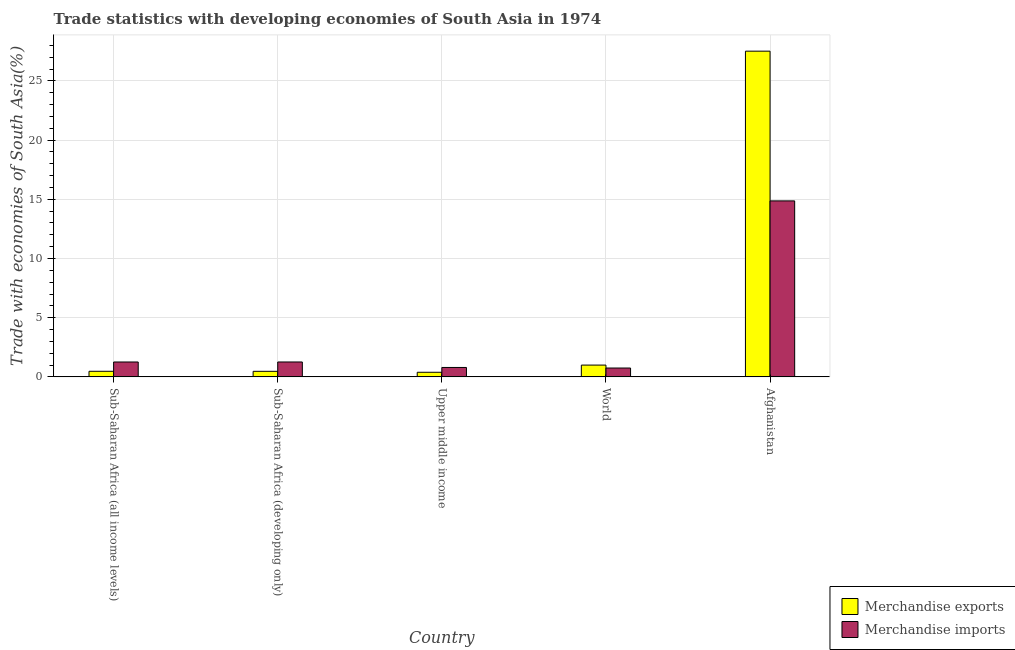Are the number of bars per tick equal to the number of legend labels?
Your answer should be very brief. Yes. Are the number of bars on each tick of the X-axis equal?
Your answer should be compact. Yes. How many bars are there on the 4th tick from the left?
Your response must be concise. 2. How many bars are there on the 2nd tick from the right?
Offer a very short reply. 2. What is the label of the 1st group of bars from the left?
Offer a very short reply. Sub-Saharan Africa (all income levels). In how many cases, is the number of bars for a given country not equal to the number of legend labels?
Your answer should be very brief. 0. What is the merchandise imports in Sub-Saharan Africa (developing only)?
Provide a short and direct response. 1.26. Across all countries, what is the maximum merchandise exports?
Offer a terse response. 27.51. Across all countries, what is the minimum merchandise exports?
Your response must be concise. 0.39. In which country was the merchandise imports maximum?
Make the answer very short. Afghanistan. What is the total merchandise exports in the graph?
Provide a short and direct response. 29.84. What is the difference between the merchandise exports in Afghanistan and that in Sub-Saharan Africa (all income levels)?
Ensure brevity in your answer.  27.04. What is the difference between the merchandise exports in Sub-Saharan Africa (all income levels) and the merchandise imports in Sub-Saharan Africa (developing only)?
Your response must be concise. -0.79. What is the average merchandise imports per country?
Provide a succinct answer. 3.78. What is the difference between the merchandise imports and merchandise exports in Sub-Saharan Africa (all income levels)?
Keep it short and to the point. 0.79. What is the ratio of the merchandise exports in Afghanistan to that in Sub-Saharan Africa (developing only)?
Provide a short and direct response. 58.75. Is the merchandise exports in Sub-Saharan Africa (all income levels) less than that in Upper middle income?
Keep it short and to the point. No. Is the difference between the merchandise exports in Afghanistan and Sub-Saharan Africa (developing only) greater than the difference between the merchandise imports in Afghanistan and Sub-Saharan Africa (developing only)?
Offer a terse response. Yes. What is the difference between the highest and the second highest merchandise exports?
Offer a very short reply. 26.52. What is the difference between the highest and the lowest merchandise exports?
Your answer should be very brief. 27.13. What does the 2nd bar from the left in Upper middle income represents?
Your answer should be compact. Merchandise imports. What does the 2nd bar from the right in Sub-Saharan Africa (all income levels) represents?
Offer a very short reply. Merchandise exports. Are all the bars in the graph horizontal?
Make the answer very short. No. Where does the legend appear in the graph?
Offer a terse response. Bottom right. What is the title of the graph?
Your answer should be very brief. Trade statistics with developing economies of South Asia in 1974. Does "Fixed telephone" appear as one of the legend labels in the graph?
Your answer should be very brief. No. What is the label or title of the Y-axis?
Provide a short and direct response. Trade with economies of South Asia(%). What is the Trade with economies of South Asia(%) of Merchandise exports in Sub-Saharan Africa (all income levels)?
Provide a short and direct response. 0.47. What is the Trade with economies of South Asia(%) of Merchandise imports in Sub-Saharan Africa (all income levels)?
Make the answer very short. 1.26. What is the Trade with economies of South Asia(%) in Merchandise exports in Sub-Saharan Africa (developing only)?
Your answer should be very brief. 0.47. What is the Trade with economies of South Asia(%) of Merchandise imports in Sub-Saharan Africa (developing only)?
Your answer should be very brief. 1.26. What is the Trade with economies of South Asia(%) of Merchandise exports in Upper middle income?
Give a very brief answer. 0.39. What is the Trade with economies of South Asia(%) in Merchandise imports in Upper middle income?
Your response must be concise. 0.79. What is the Trade with economies of South Asia(%) of Merchandise exports in World?
Make the answer very short. 1. What is the Trade with economies of South Asia(%) in Merchandise imports in World?
Give a very brief answer. 0.75. What is the Trade with economies of South Asia(%) in Merchandise exports in Afghanistan?
Offer a very short reply. 27.51. What is the Trade with economies of South Asia(%) in Merchandise imports in Afghanistan?
Provide a short and direct response. 14.87. Across all countries, what is the maximum Trade with economies of South Asia(%) in Merchandise exports?
Offer a terse response. 27.51. Across all countries, what is the maximum Trade with economies of South Asia(%) of Merchandise imports?
Your answer should be compact. 14.87. Across all countries, what is the minimum Trade with economies of South Asia(%) of Merchandise exports?
Provide a succinct answer. 0.39. Across all countries, what is the minimum Trade with economies of South Asia(%) in Merchandise imports?
Your response must be concise. 0.75. What is the total Trade with economies of South Asia(%) of Merchandise exports in the graph?
Provide a succinct answer. 29.84. What is the total Trade with economies of South Asia(%) of Merchandise imports in the graph?
Make the answer very short. 18.92. What is the difference between the Trade with economies of South Asia(%) of Merchandise exports in Sub-Saharan Africa (all income levels) and that in Sub-Saharan Africa (developing only)?
Provide a succinct answer. 0. What is the difference between the Trade with economies of South Asia(%) of Merchandise imports in Sub-Saharan Africa (all income levels) and that in Sub-Saharan Africa (developing only)?
Offer a very short reply. -0. What is the difference between the Trade with economies of South Asia(%) of Merchandise exports in Sub-Saharan Africa (all income levels) and that in Upper middle income?
Your answer should be compact. 0.08. What is the difference between the Trade with economies of South Asia(%) of Merchandise imports in Sub-Saharan Africa (all income levels) and that in Upper middle income?
Provide a short and direct response. 0.46. What is the difference between the Trade with economies of South Asia(%) in Merchandise exports in Sub-Saharan Africa (all income levels) and that in World?
Your answer should be very brief. -0.52. What is the difference between the Trade with economies of South Asia(%) in Merchandise imports in Sub-Saharan Africa (all income levels) and that in World?
Offer a terse response. 0.51. What is the difference between the Trade with economies of South Asia(%) of Merchandise exports in Sub-Saharan Africa (all income levels) and that in Afghanistan?
Ensure brevity in your answer.  -27.04. What is the difference between the Trade with economies of South Asia(%) of Merchandise imports in Sub-Saharan Africa (all income levels) and that in Afghanistan?
Your answer should be compact. -13.61. What is the difference between the Trade with economies of South Asia(%) in Merchandise exports in Sub-Saharan Africa (developing only) and that in Upper middle income?
Provide a succinct answer. 0.08. What is the difference between the Trade with economies of South Asia(%) of Merchandise imports in Sub-Saharan Africa (developing only) and that in Upper middle income?
Keep it short and to the point. 0.46. What is the difference between the Trade with economies of South Asia(%) in Merchandise exports in Sub-Saharan Africa (developing only) and that in World?
Give a very brief answer. -0.53. What is the difference between the Trade with economies of South Asia(%) in Merchandise imports in Sub-Saharan Africa (developing only) and that in World?
Offer a very short reply. 0.51. What is the difference between the Trade with economies of South Asia(%) in Merchandise exports in Sub-Saharan Africa (developing only) and that in Afghanistan?
Keep it short and to the point. -27.05. What is the difference between the Trade with economies of South Asia(%) of Merchandise imports in Sub-Saharan Africa (developing only) and that in Afghanistan?
Keep it short and to the point. -13.61. What is the difference between the Trade with economies of South Asia(%) of Merchandise exports in Upper middle income and that in World?
Your answer should be very brief. -0.61. What is the difference between the Trade with economies of South Asia(%) in Merchandise imports in Upper middle income and that in World?
Give a very brief answer. 0.05. What is the difference between the Trade with economies of South Asia(%) in Merchandise exports in Upper middle income and that in Afghanistan?
Keep it short and to the point. -27.13. What is the difference between the Trade with economies of South Asia(%) of Merchandise imports in Upper middle income and that in Afghanistan?
Keep it short and to the point. -14.07. What is the difference between the Trade with economies of South Asia(%) of Merchandise exports in World and that in Afghanistan?
Your response must be concise. -26.52. What is the difference between the Trade with economies of South Asia(%) of Merchandise imports in World and that in Afghanistan?
Ensure brevity in your answer.  -14.12. What is the difference between the Trade with economies of South Asia(%) of Merchandise exports in Sub-Saharan Africa (all income levels) and the Trade with economies of South Asia(%) of Merchandise imports in Sub-Saharan Africa (developing only)?
Your answer should be compact. -0.79. What is the difference between the Trade with economies of South Asia(%) of Merchandise exports in Sub-Saharan Africa (all income levels) and the Trade with economies of South Asia(%) of Merchandise imports in Upper middle income?
Offer a terse response. -0.32. What is the difference between the Trade with economies of South Asia(%) of Merchandise exports in Sub-Saharan Africa (all income levels) and the Trade with economies of South Asia(%) of Merchandise imports in World?
Offer a terse response. -0.28. What is the difference between the Trade with economies of South Asia(%) of Merchandise exports in Sub-Saharan Africa (all income levels) and the Trade with economies of South Asia(%) of Merchandise imports in Afghanistan?
Give a very brief answer. -14.39. What is the difference between the Trade with economies of South Asia(%) in Merchandise exports in Sub-Saharan Africa (developing only) and the Trade with economies of South Asia(%) in Merchandise imports in Upper middle income?
Your response must be concise. -0.33. What is the difference between the Trade with economies of South Asia(%) of Merchandise exports in Sub-Saharan Africa (developing only) and the Trade with economies of South Asia(%) of Merchandise imports in World?
Your response must be concise. -0.28. What is the difference between the Trade with economies of South Asia(%) in Merchandise exports in Sub-Saharan Africa (developing only) and the Trade with economies of South Asia(%) in Merchandise imports in Afghanistan?
Your answer should be very brief. -14.4. What is the difference between the Trade with economies of South Asia(%) of Merchandise exports in Upper middle income and the Trade with economies of South Asia(%) of Merchandise imports in World?
Ensure brevity in your answer.  -0.36. What is the difference between the Trade with economies of South Asia(%) in Merchandise exports in Upper middle income and the Trade with economies of South Asia(%) in Merchandise imports in Afghanistan?
Offer a very short reply. -14.48. What is the difference between the Trade with economies of South Asia(%) in Merchandise exports in World and the Trade with economies of South Asia(%) in Merchandise imports in Afghanistan?
Ensure brevity in your answer.  -13.87. What is the average Trade with economies of South Asia(%) of Merchandise exports per country?
Ensure brevity in your answer.  5.97. What is the average Trade with economies of South Asia(%) in Merchandise imports per country?
Make the answer very short. 3.78. What is the difference between the Trade with economies of South Asia(%) of Merchandise exports and Trade with economies of South Asia(%) of Merchandise imports in Sub-Saharan Africa (all income levels)?
Keep it short and to the point. -0.79. What is the difference between the Trade with economies of South Asia(%) in Merchandise exports and Trade with economies of South Asia(%) in Merchandise imports in Sub-Saharan Africa (developing only)?
Keep it short and to the point. -0.79. What is the difference between the Trade with economies of South Asia(%) in Merchandise exports and Trade with economies of South Asia(%) in Merchandise imports in Upper middle income?
Your response must be concise. -0.41. What is the difference between the Trade with economies of South Asia(%) of Merchandise exports and Trade with economies of South Asia(%) of Merchandise imports in World?
Ensure brevity in your answer.  0.25. What is the difference between the Trade with economies of South Asia(%) of Merchandise exports and Trade with economies of South Asia(%) of Merchandise imports in Afghanistan?
Offer a terse response. 12.65. What is the ratio of the Trade with economies of South Asia(%) of Merchandise exports in Sub-Saharan Africa (all income levels) to that in Sub-Saharan Africa (developing only)?
Provide a succinct answer. 1.01. What is the ratio of the Trade with economies of South Asia(%) in Merchandise imports in Sub-Saharan Africa (all income levels) to that in Sub-Saharan Africa (developing only)?
Ensure brevity in your answer.  1. What is the ratio of the Trade with economies of South Asia(%) of Merchandise exports in Sub-Saharan Africa (all income levels) to that in Upper middle income?
Your response must be concise. 1.21. What is the ratio of the Trade with economies of South Asia(%) of Merchandise imports in Sub-Saharan Africa (all income levels) to that in Upper middle income?
Your answer should be very brief. 1.58. What is the ratio of the Trade with economies of South Asia(%) of Merchandise exports in Sub-Saharan Africa (all income levels) to that in World?
Provide a short and direct response. 0.47. What is the ratio of the Trade with economies of South Asia(%) in Merchandise imports in Sub-Saharan Africa (all income levels) to that in World?
Keep it short and to the point. 1.68. What is the ratio of the Trade with economies of South Asia(%) of Merchandise exports in Sub-Saharan Africa (all income levels) to that in Afghanistan?
Provide a short and direct response. 0.02. What is the ratio of the Trade with economies of South Asia(%) in Merchandise imports in Sub-Saharan Africa (all income levels) to that in Afghanistan?
Ensure brevity in your answer.  0.08. What is the ratio of the Trade with economies of South Asia(%) in Merchandise exports in Sub-Saharan Africa (developing only) to that in Upper middle income?
Make the answer very short. 1.21. What is the ratio of the Trade with economies of South Asia(%) of Merchandise imports in Sub-Saharan Africa (developing only) to that in Upper middle income?
Your answer should be very brief. 1.58. What is the ratio of the Trade with economies of South Asia(%) of Merchandise exports in Sub-Saharan Africa (developing only) to that in World?
Keep it short and to the point. 0.47. What is the ratio of the Trade with economies of South Asia(%) of Merchandise imports in Sub-Saharan Africa (developing only) to that in World?
Ensure brevity in your answer.  1.68. What is the ratio of the Trade with economies of South Asia(%) of Merchandise exports in Sub-Saharan Africa (developing only) to that in Afghanistan?
Offer a very short reply. 0.02. What is the ratio of the Trade with economies of South Asia(%) of Merchandise imports in Sub-Saharan Africa (developing only) to that in Afghanistan?
Your answer should be compact. 0.08. What is the ratio of the Trade with economies of South Asia(%) in Merchandise exports in Upper middle income to that in World?
Give a very brief answer. 0.39. What is the ratio of the Trade with economies of South Asia(%) in Merchandise imports in Upper middle income to that in World?
Make the answer very short. 1.06. What is the ratio of the Trade with economies of South Asia(%) of Merchandise exports in Upper middle income to that in Afghanistan?
Offer a terse response. 0.01. What is the ratio of the Trade with economies of South Asia(%) in Merchandise imports in Upper middle income to that in Afghanistan?
Offer a terse response. 0.05. What is the ratio of the Trade with economies of South Asia(%) of Merchandise exports in World to that in Afghanistan?
Your answer should be very brief. 0.04. What is the ratio of the Trade with economies of South Asia(%) of Merchandise imports in World to that in Afghanistan?
Your response must be concise. 0.05. What is the difference between the highest and the second highest Trade with economies of South Asia(%) in Merchandise exports?
Your response must be concise. 26.52. What is the difference between the highest and the second highest Trade with economies of South Asia(%) of Merchandise imports?
Provide a short and direct response. 13.61. What is the difference between the highest and the lowest Trade with economies of South Asia(%) of Merchandise exports?
Make the answer very short. 27.13. What is the difference between the highest and the lowest Trade with economies of South Asia(%) in Merchandise imports?
Provide a succinct answer. 14.12. 